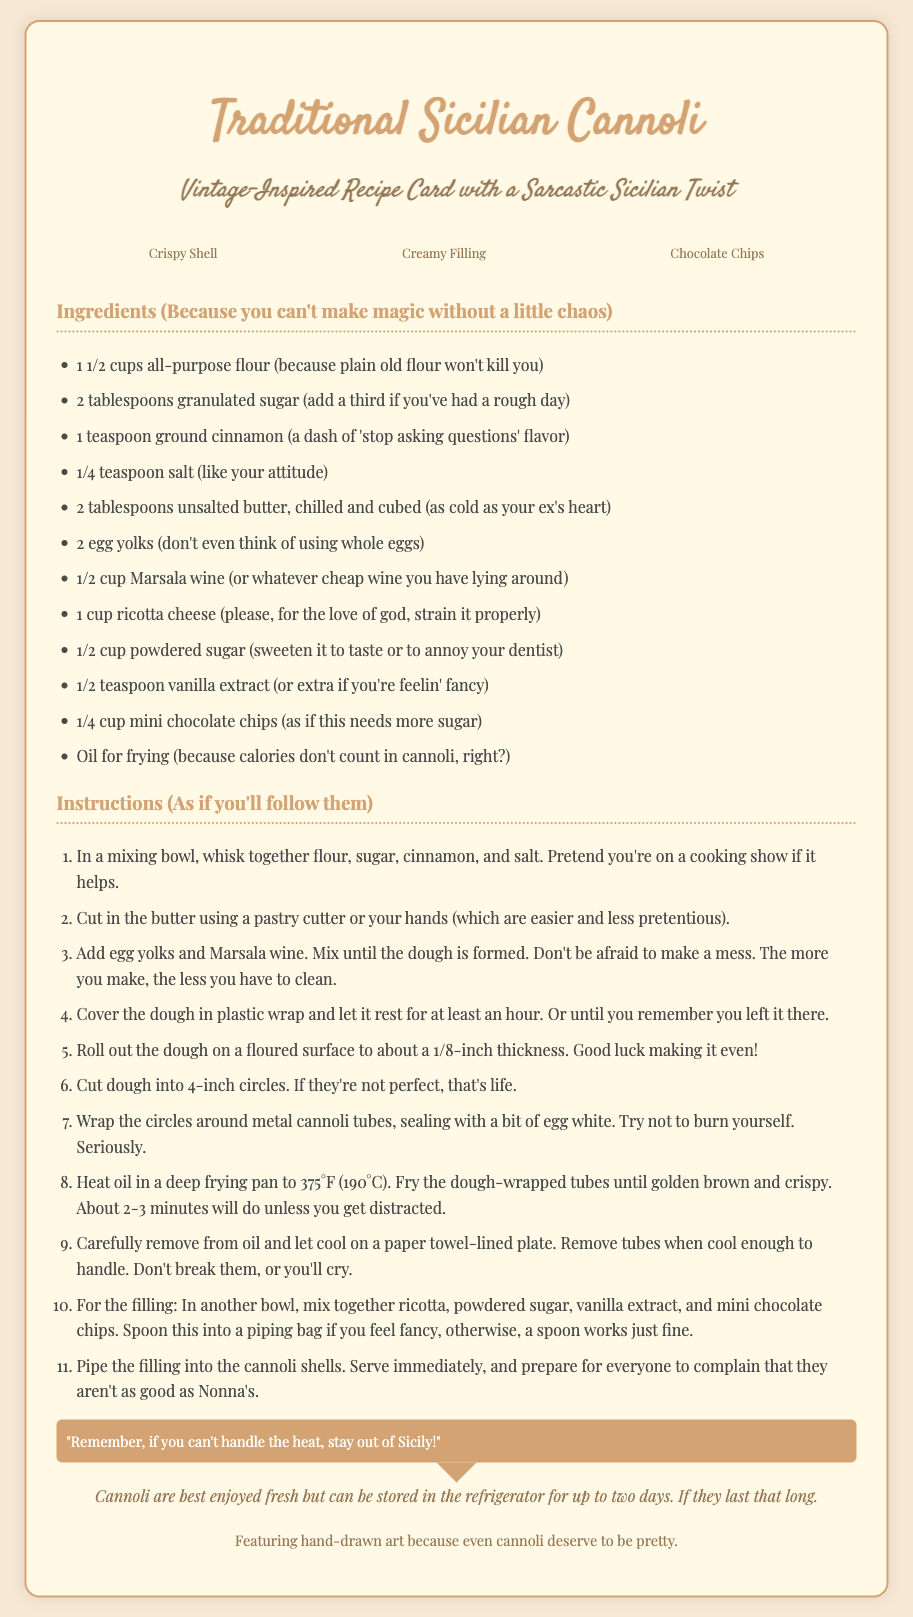What is the title of the recipe? The title is the first heading in the document, which describes the type of recipe being presented.
Answer: Traditional Sicilian Cannoli How many egg yolks are needed? The ingredient list specifies the exact quantity of egg yolks required to make the cannoli.
Answer: 2 What is the suggested wine for this recipe? The ingredients section mentions a specific type of wine that can be used in the recipe.
Answer: Marsala wine What temperature should the oil be heated to? The instructions provide specific temperature details necessary for frying the cannoli.
Answer: 375°F How long should the dough rest? The instructions indicate the required duration for the dough to rest before proceeding with the recipe.
Answer: At least an hour What does the note say about cannoli shelf life? The note section provides information regarding how long the cannoli can be stored.
Answer: Up to two days What decorative style features in this card? The document highlights the artistic aspect that enhances the recipe presentation.
Answer: Hand-drawn art What is the main sarcastic phrase in the speech bubble? The speech bubble contains a humorous remark related to cooking and the heat of the environment.
Answer: "Remember, if you can't handle the heat, stay out of Sicily!" What is the purpose of the art description section? The art description explains the artistic element that complements the recipe.
Answer: To highlight the hand-drawn art 